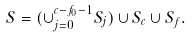Convert formula to latex. <formula><loc_0><loc_0><loc_500><loc_500>S = ( \cup _ { j = 0 } ^ { c - f _ { 0 } - 1 } S _ { j } ) \cup S _ { c } \cup S _ { f } .</formula> 